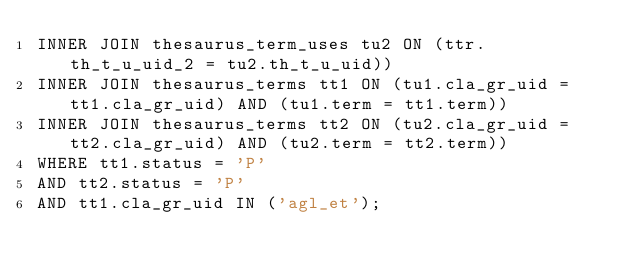Convert code to text. <code><loc_0><loc_0><loc_500><loc_500><_SQL_>INNER JOIN thesaurus_term_uses tu2 ON (ttr.th_t_u_uid_2 = tu2.th_t_u_uid))
INNER JOIN thesaurus_terms tt1 ON (tu1.cla_gr_uid = tt1.cla_gr_uid) AND (tu1.term = tt1.term))
INNER JOIN thesaurus_terms tt2 ON (tu2.cla_gr_uid = tt2.cla_gr_uid) AND (tu2.term = tt2.term))
WHERE	tt1.status = 'P' 
AND	tt2.status = 'P'
AND	tt1.cla_gr_uid IN ('agl_et');
</code> 